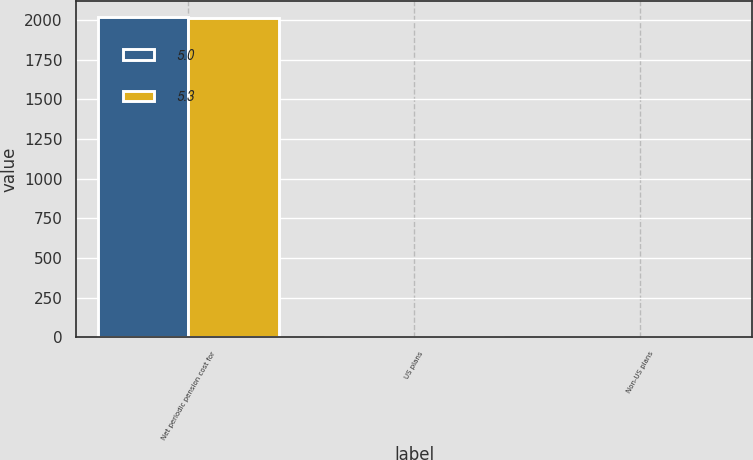<chart> <loc_0><loc_0><loc_500><loc_500><stacked_bar_chart><ecel><fcel>Net periodic pension cost for<fcel>US plans<fcel>Non-US plans<nl><fcel>5<fcel>2015<fcel>4<fcel>3.7<nl><fcel>5.3<fcel>2014<fcel>5<fcel>4.5<nl></chart> 